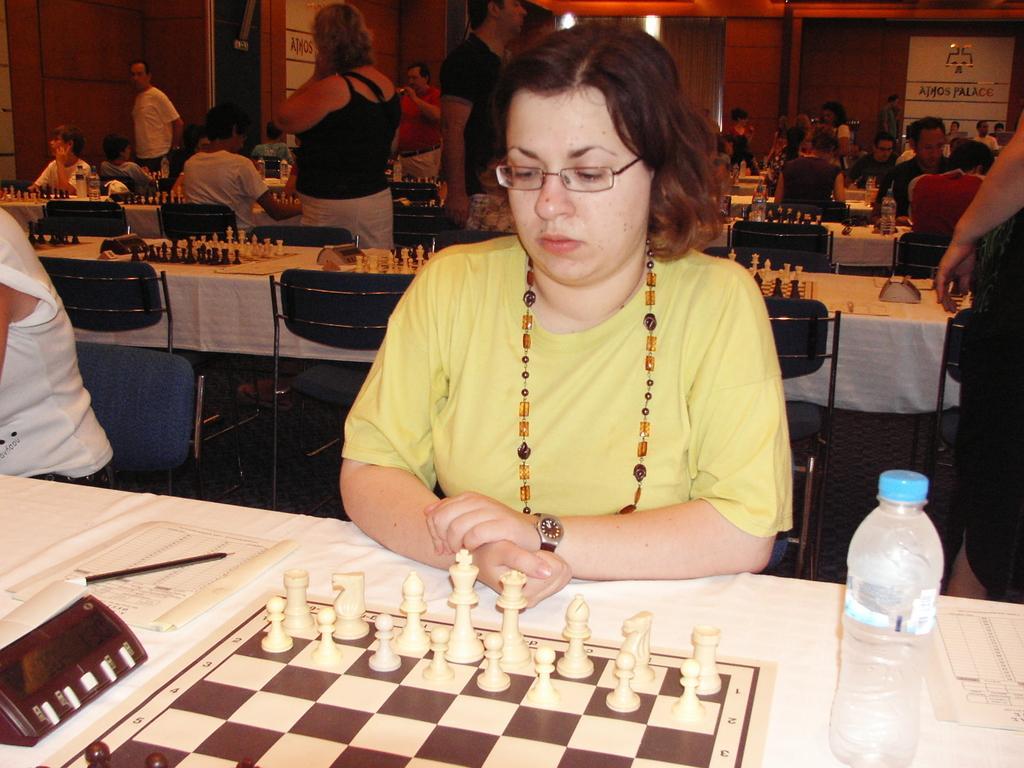Describe this image in one or two sentences. Few people sitting on chair. These persons standing. We can able to see tables and chair. On the table we can see chess,book,pen,bottle. On the background we can see wall. 